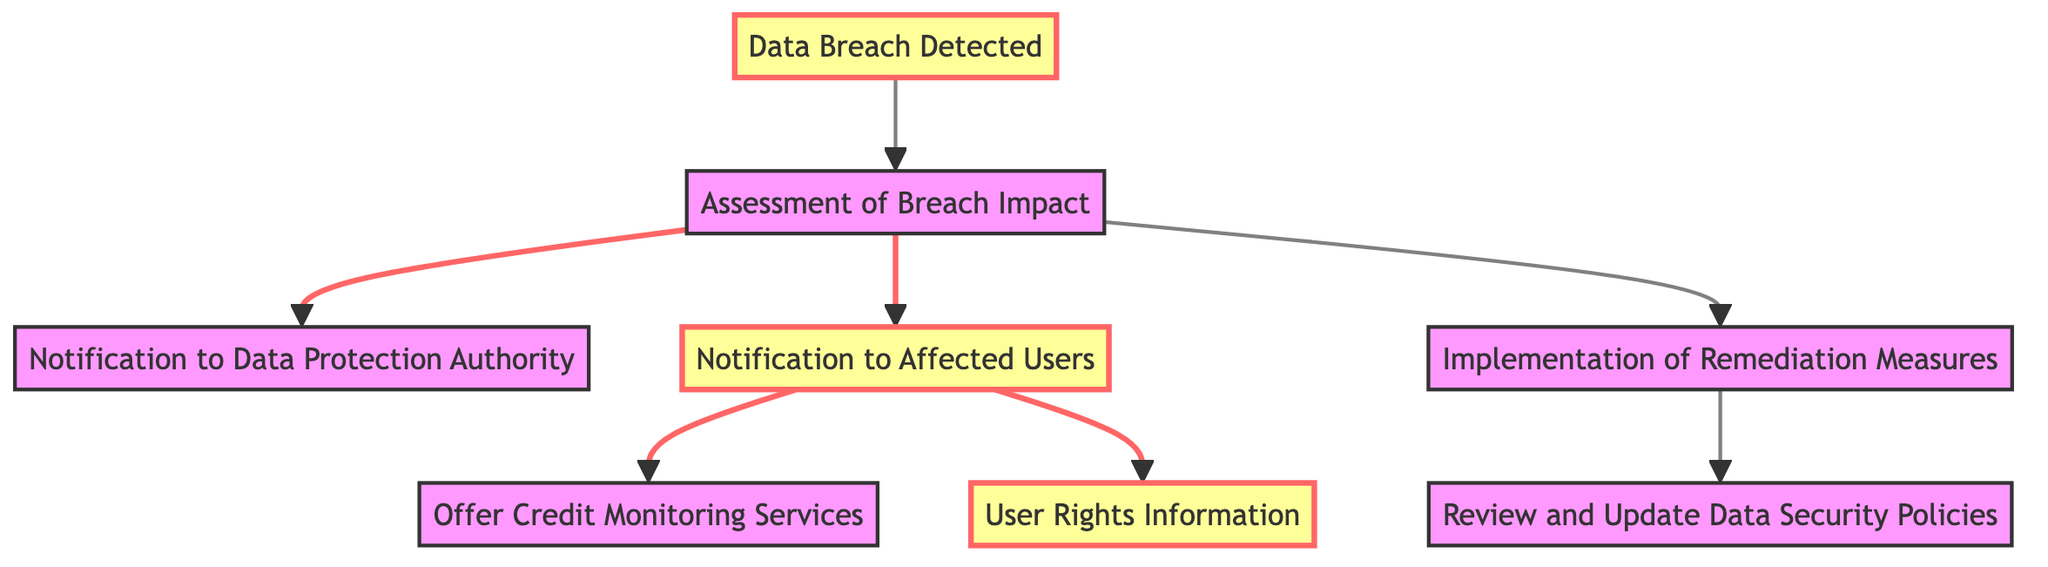What is the first step in the data breach incident? The diagram shows that the first step is "Data Breach Detected," which is the initial action taken in the sequence of events.
Answer: Data Breach Detected How many nodes are in the diagram? By counting the listed nodes in the data, we identified that there are 8 distinct nodes present in the diagram.
Answer: 8 What node follows "Assessment of Breach Impact"? The diagram indicates that after "Assessment of Breach Impact," there are several outcomes, one directly leading to "Notification to Data Protection Authority" and another to "Notification to Affected Users." However, the question asks for the immediate next actions. The answer is "Notification to Data Protection Authority."
Answer: Notification to Data Protection Authority Which node provides information about users' rights? The diagram highlights that the "User Rights Information" node is an outcome of notifying affected users. Thus, it specifically addresses users' rights following a breach.
Answer: User Rights Information What is the relationship between "Notification to Affected Users" and "Offer Credit Monitoring Services"? The diagram shows a direct flow from "Notification to Affected Users" to "Offer Credit Monitoring Services," indicating that credit monitoring offers occur as a response to notifying users about the breach.
Answer: Direct flow Which node is connected to "Implementation of Remediation Measures"? The diagram shows a direct connection from "Assessment of Breach Impact" to "Implementation of Remediation Measures," indicating the measures that should be put in place following the assessment.
Answer: Implementation of Remediation Measures How many edges are there in the directed graph? By examining the connections in the edges list, we tallied a total of 7 edges, which represent the directed relationships between the nodes in the graph.
Answer: 7 What node results from implementing remediation measures? The diagram indicates that "Review and Update Data Security Policies" is the action taken after "Implementation of Remediation Measures," making it the resultant node.
Answer: Review and Update Data Security Policies 